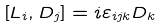<formula> <loc_0><loc_0><loc_500><loc_500>\left [ L _ { i } , D _ { j } \right ] = i \varepsilon _ { i j k } D _ { k }</formula> 